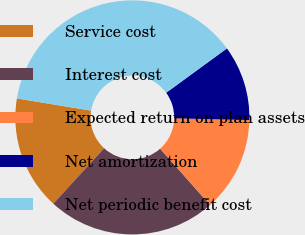Convert chart to OTSL. <chart><loc_0><loc_0><loc_500><loc_500><pie_chart><fcel>Service cost<fcel>Interest cost<fcel>Expected return on plan assets<fcel>Net amortization<fcel>Net periodic benefit cost<nl><fcel>15.79%<fcel>23.35%<fcel>13.09%<fcel>10.39%<fcel>37.37%<nl></chart> 